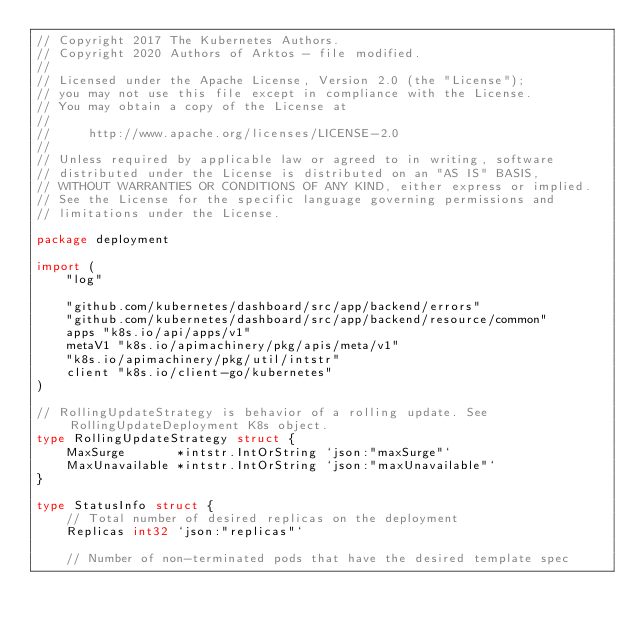Convert code to text. <code><loc_0><loc_0><loc_500><loc_500><_Go_>// Copyright 2017 The Kubernetes Authors.
// Copyright 2020 Authors of Arktos - file modified.
//
// Licensed under the Apache License, Version 2.0 (the "License");
// you may not use this file except in compliance with the License.
// You may obtain a copy of the License at
//
//     http://www.apache.org/licenses/LICENSE-2.0
//
// Unless required by applicable law or agreed to in writing, software
// distributed under the License is distributed on an "AS IS" BASIS,
// WITHOUT WARRANTIES OR CONDITIONS OF ANY KIND, either express or implied.
// See the License for the specific language governing permissions and
// limitations under the License.

package deployment

import (
	"log"

	"github.com/kubernetes/dashboard/src/app/backend/errors"
	"github.com/kubernetes/dashboard/src/app/backend/resource/common"
	apps "k8s.io/api/apps/v1"
	metaV1 "k8s.io/apimachinery/pkg/apis/meta/v1"
	"k8s.io/apimachinery/pkg/util/intstr"
	client "k8s.io/client-go/kubernetes"
)

// RollingUpdateStrategy is behavior of a rolling update. See RollingUpdateDeployment K8s object.
type RollingUpdateStrategy struct {
	MaxSurge       *intstr.IntOrString `json:"maxSurge"`
	MaxUnavailable *intstr.IntOrString `json:"maxUnavailable"`
}

type StatusInfo struct {
	// Total number of desired replicas on the deployment
	Replicas int32 `json:"replicas"`

	// Number of non-terminated pods that have the desired template spec</code> 